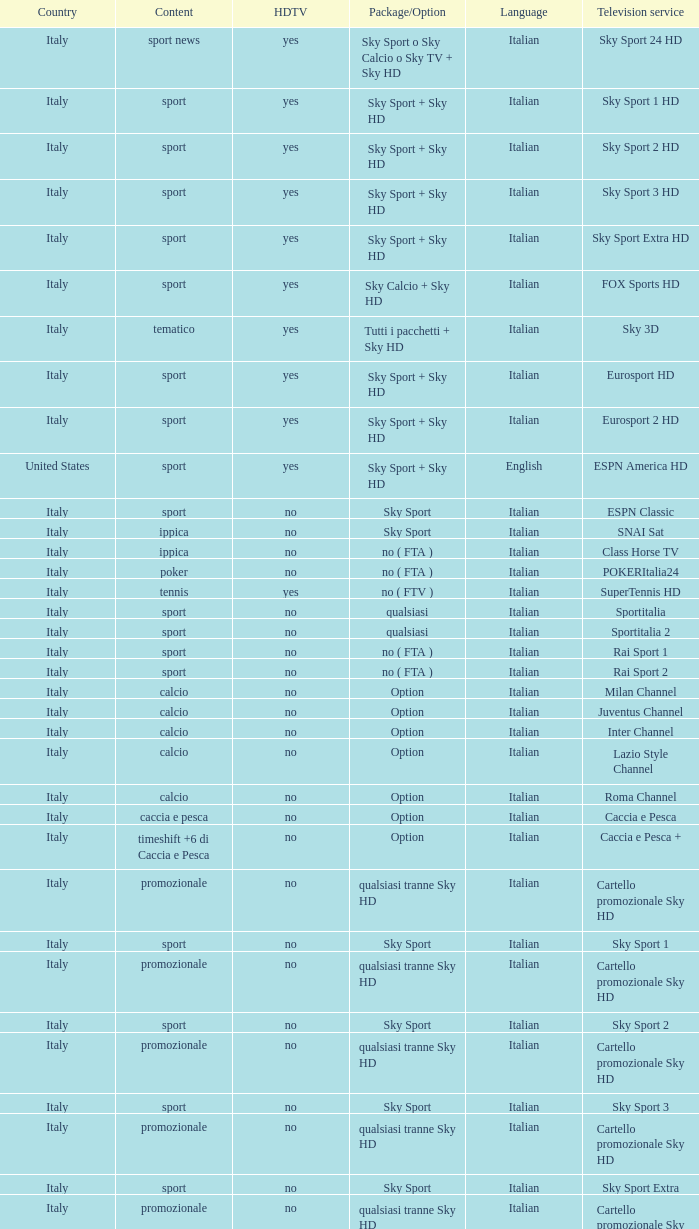What is Country, when Television Service is Eurosport 2? Italy. 